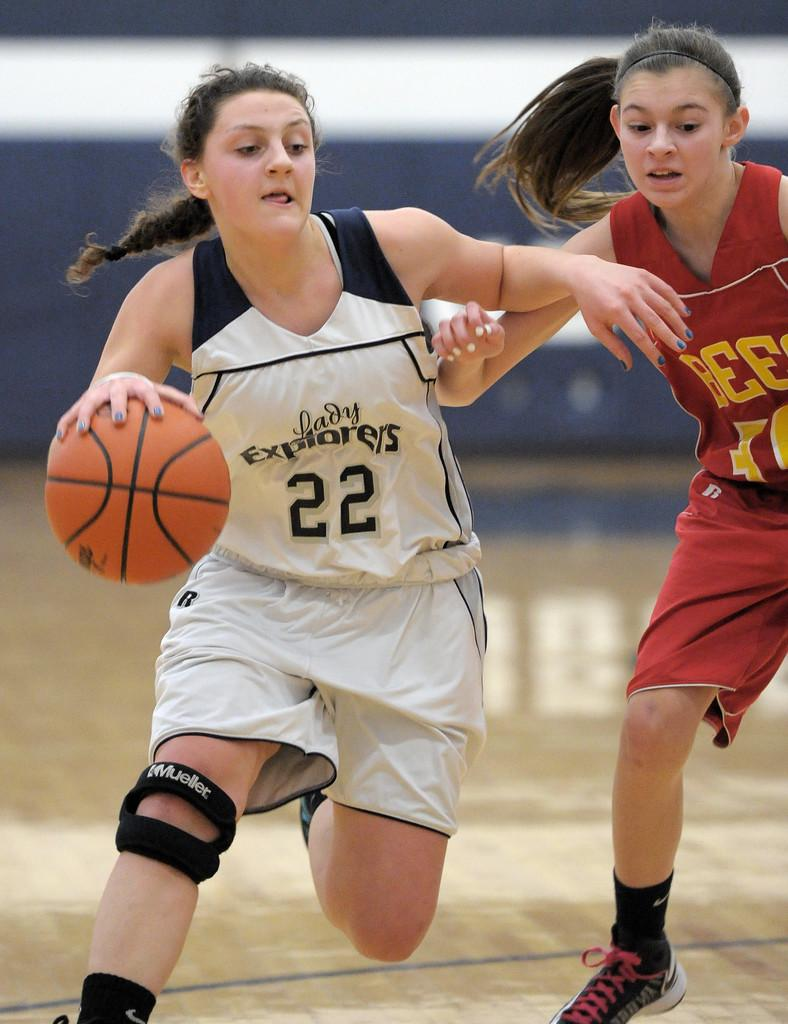<image>
Summarize the visual content of the image. Two female basketball players are running on the court and the player with the Explorers 22 jersey has the ball. 